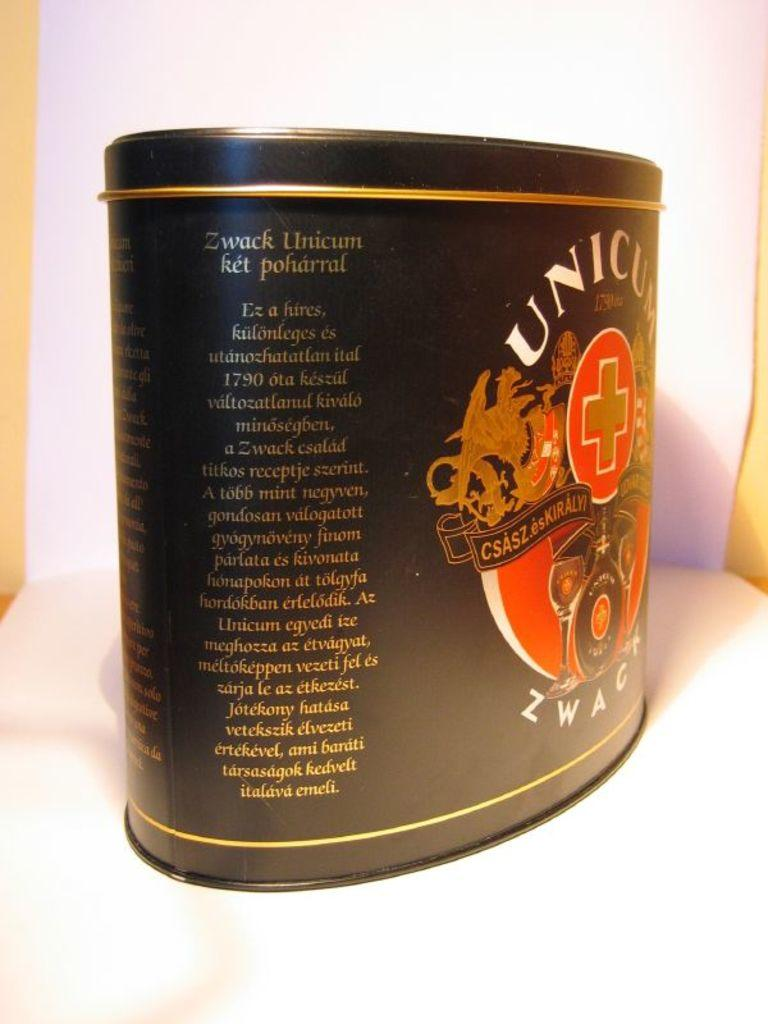<image>
Render a clear and concise summary of the photo. A container of Zwack Unicum turned to the description label. 